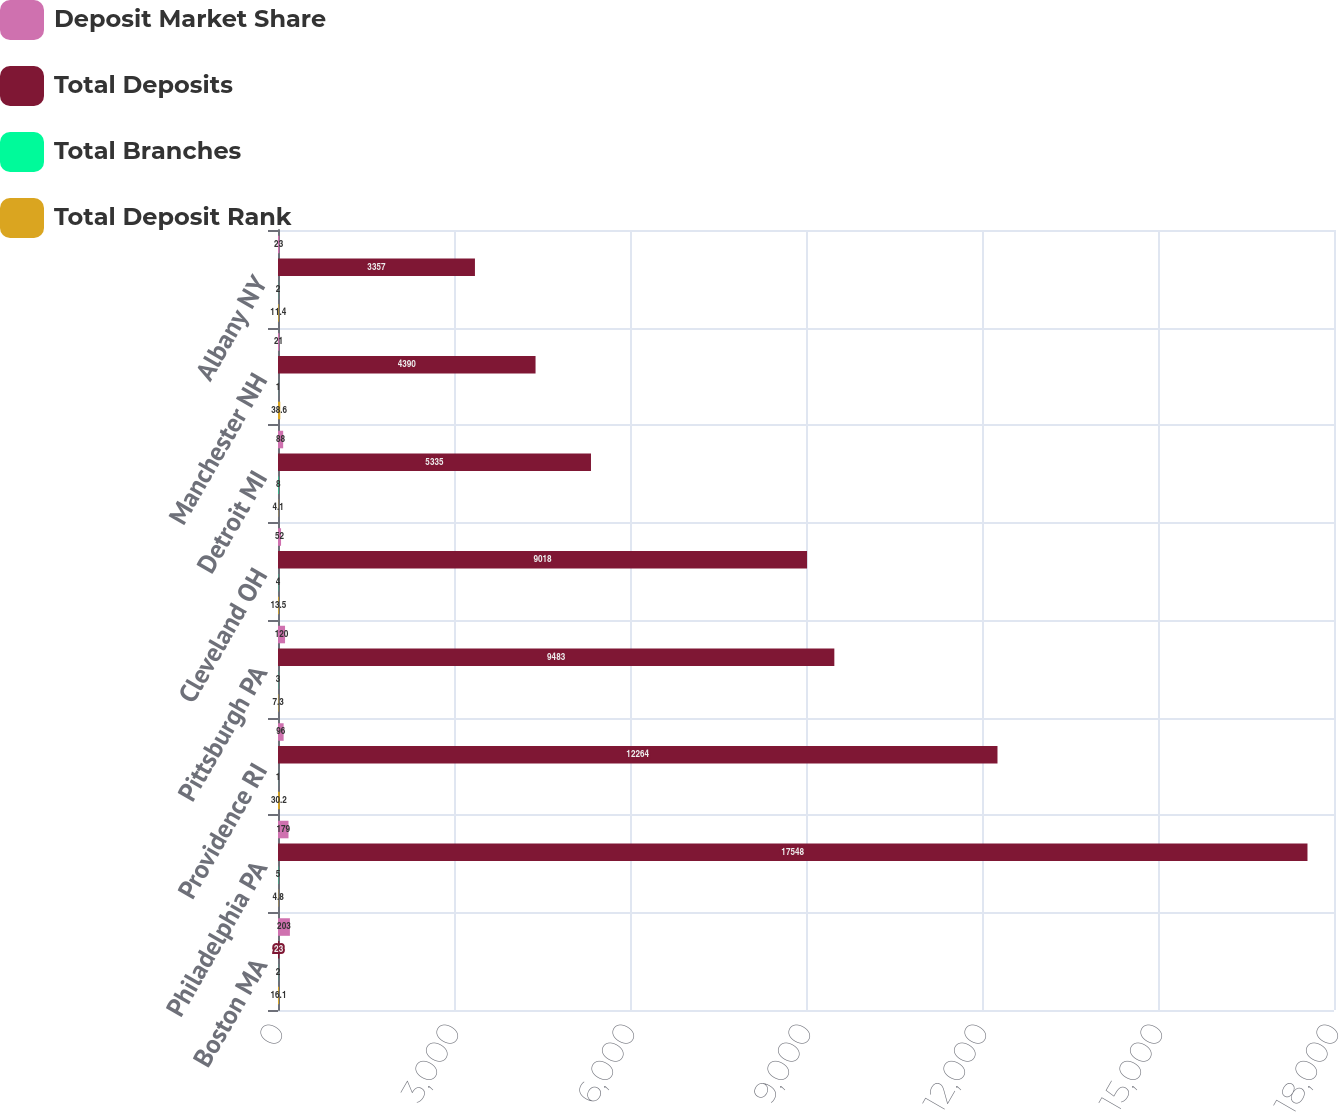Convert chart to OTSL. <chart><loc_0><loc_0><loc_500><loc_500><stacked_bar_chart><ecel><fcel>Boston MA<fcel>Philadelphia PA<fcel>Providence RI<fcel>Pittsburgh PA<fcel>Cleveland OH<fcel>Detroit MI<fcel>Manchester NH<fcel>Albany NY<nl><fcel>Deposit Market Share<fcel>203<fcel>179<fcel>96<fcel>120<fcel>52<fcel>88<fcel>21<fcel>23<nl><fcel>Total Deposits<fcel>23<fcel>17548<fcel>12264<fcel>9483<fcel>9018<fcel>5335<fcel>4390<fcel>3357<nl><fcel>Total Branches<fcel>2<fcel>5<fcel>1<fcel>3<fcel>4<fcel>8<fcel>1<fcel>2<nl><fcel>Total Deposit Rank<fcel>16.1<fcel>4.8<fcel>30.2<fcel>7.3<fcel>13.5<fcel>4.1<fcel>38.6<fcel>11.4<nl></chart> 